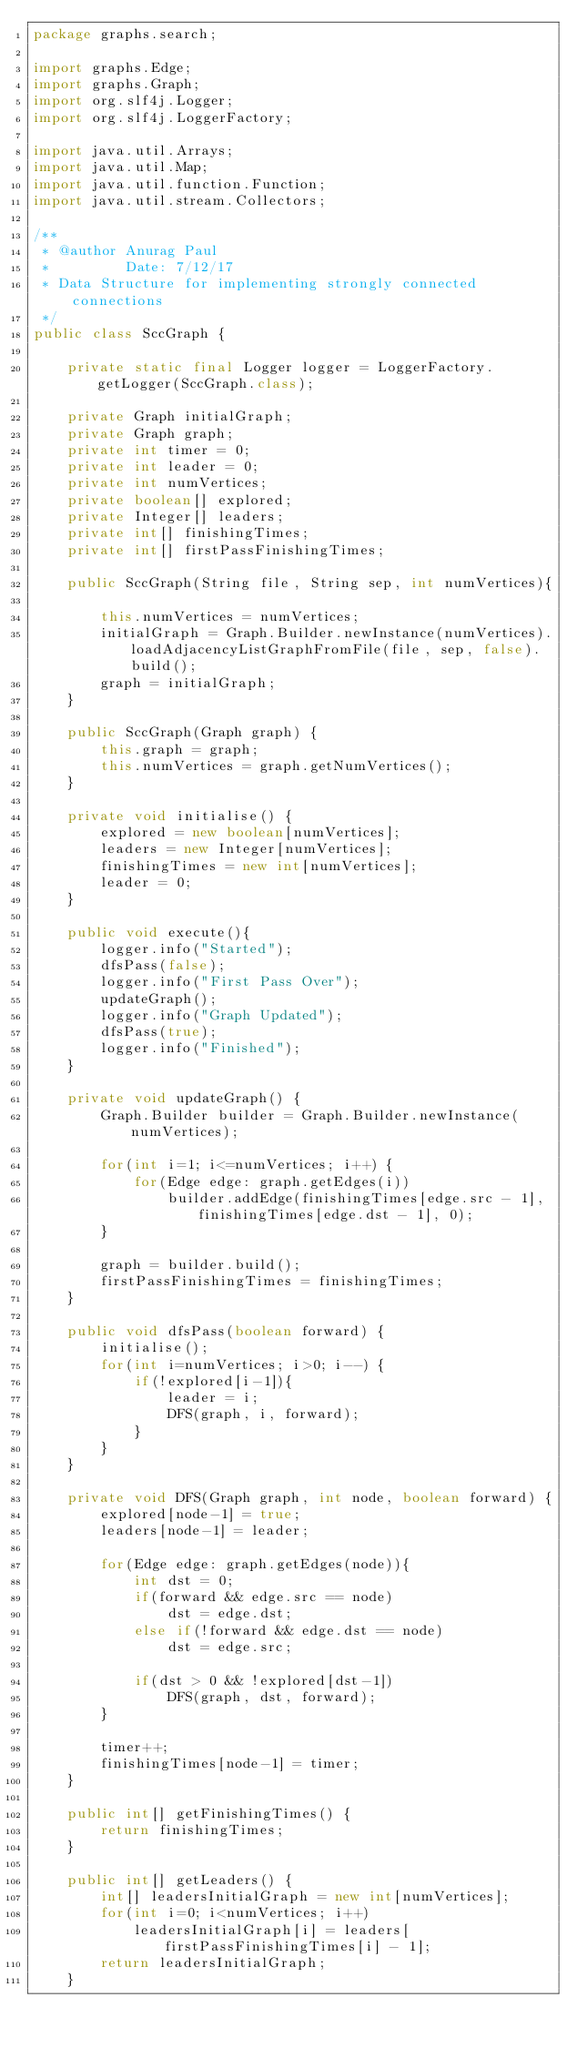Convert code to text. <code><loc_0><loc_0><loc_500><loc_500><_Java_>package graphs.search;

import graphs.Edge;
import graphs.Graph;
import org.slf4j.Logger;
import org.slf4j.LoggerFactory;

import java.util.Arrays;
import java.util.Map;
import java.util.function.Function;
import java.util.stream.Collectors;

/**
 * @author Anurag Paul
 *         Date: 7/12/17
 * Data Structure for implementing strongly connected connections
 */
public class SccGraph {

    private static final Logger logger = LoggerFactory.getLogger(SccGraph.class);

    private Graph initialGraph;
    private Graph graph;
    private int timer = 0;
    private int leader = 0;
    private int numVertices;
    private boolean[] explored;
    private Integer[] leaders;
    private int[] finishingTimes;
    private int[] firstPassFinishingTimes;

    public SccGraph(String file, String sep, int numVertices){

        this.numVertices = numVertices;
        initialGraph = Graph.Builder.newInstance(numVertices).loadAdjacencyListGraphFromFile(file, sep, false).build();
        graph = initialGraph;
    }

    public SccGraph(Graph graph) {
        this.graph = graph;
        this.numVertices = graph.getNumVertices();
    }

    private void initialise() {
        explored = new boolean[numVertices];
        leaders = new Integer[numVertices];
        finishingTimes = new int[numVertices];
        leader = 0;
    }

    public void execute(){
        logger.info("Started");
        dfsPass(false);
        logger.info("First Pass Over");
        updateGraph();
        logger.info("Graph Updated");
        dfsPass(true);
        logger.info("Finished");
    }

    private void updateGraph() {
        Graph.Builder builder = Graph.Builder.newInstance(numVertices);

        for(int i=1; i<=numVertices; i++) {
            for(Edge edge: graph.getEdges(i))
                builder.addEdge(finishingTimes[edge.src - 1], finishingTimes[edge.dst - 1], 0);
        }

        graph = builder.build();
        firstPassFinishingTimes = finishingTimes;
    }

    public void dfsPass(boolean forward) {
        initialise();
        for(int i=numVertices; i>0; i--) {
            if(!explored[i-1]){
                leader = i;
                DFS(graph, i, forward);
            }
        }
    }

    private void DFS(Graph graph, int node, boolean forward) {
        explored[node-1] = true;
        leaders[node-1] = leader;

        for(Edge edge: graph.getEdges(node)){
            int dst = 0;
            if(forward && edge.src == node)
                dst = edge.dst;
            else if(!forward && edge.dst == node)
                dst = edge.src;

            if(dst > 0 && !explored[dst-1])
                DFS(graph, dst, forward);
        }

        timer++;
        finishingTimes[node-1] = timer;
    }

    public int[] getFinishingTimes() {
        return finishingTimes;
    }

    public int[] getLeaders() {
        int[] leadersInitialGraph = new int[numVertices];
        for(int i=0; i<numVertices; i++)
            leadersInitialGraph[i] = leaders[firstPassFinishingTimes[i] - 1];
        return leadersInitialGraph;
    }
</code> 